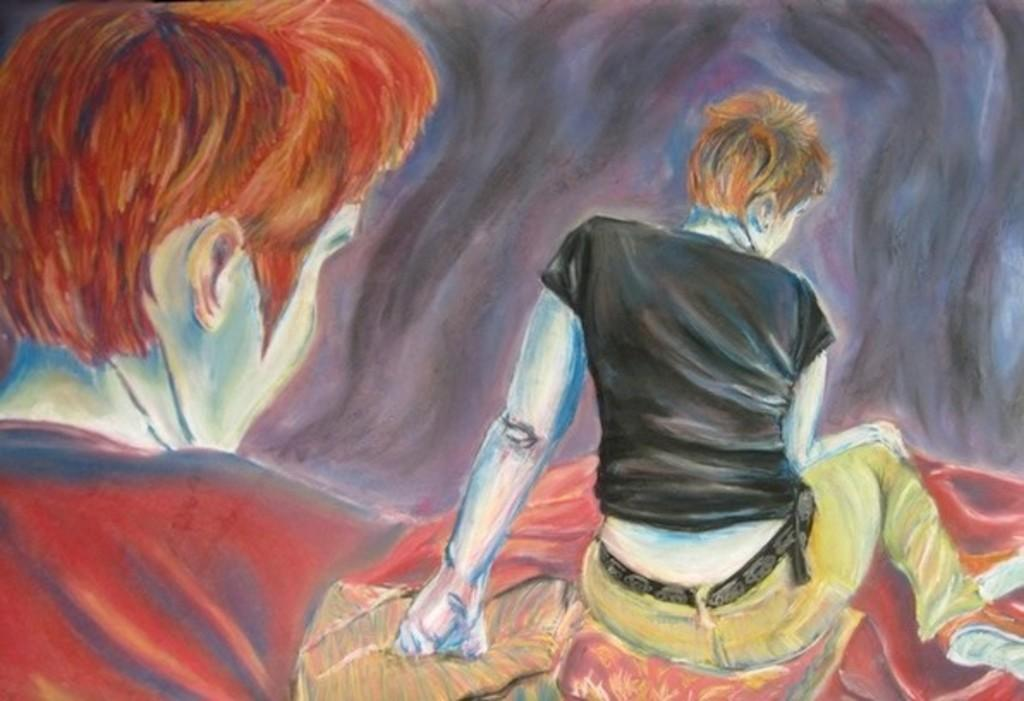What is the main subject of the image? The main subject of the image is a painting. What is depicted in the painting? The painting contains two people. What are the two people in the painting wearing? The two people in the painting are wearing clothes. What type of print can be seen being produced by the two people in the image? There is no reference to a print or production process in the image; it features a painting with two people. What is the desire of the two people in the painting? There is no indication of the desires or intentions of the two people in the painting, as it is a static image. 